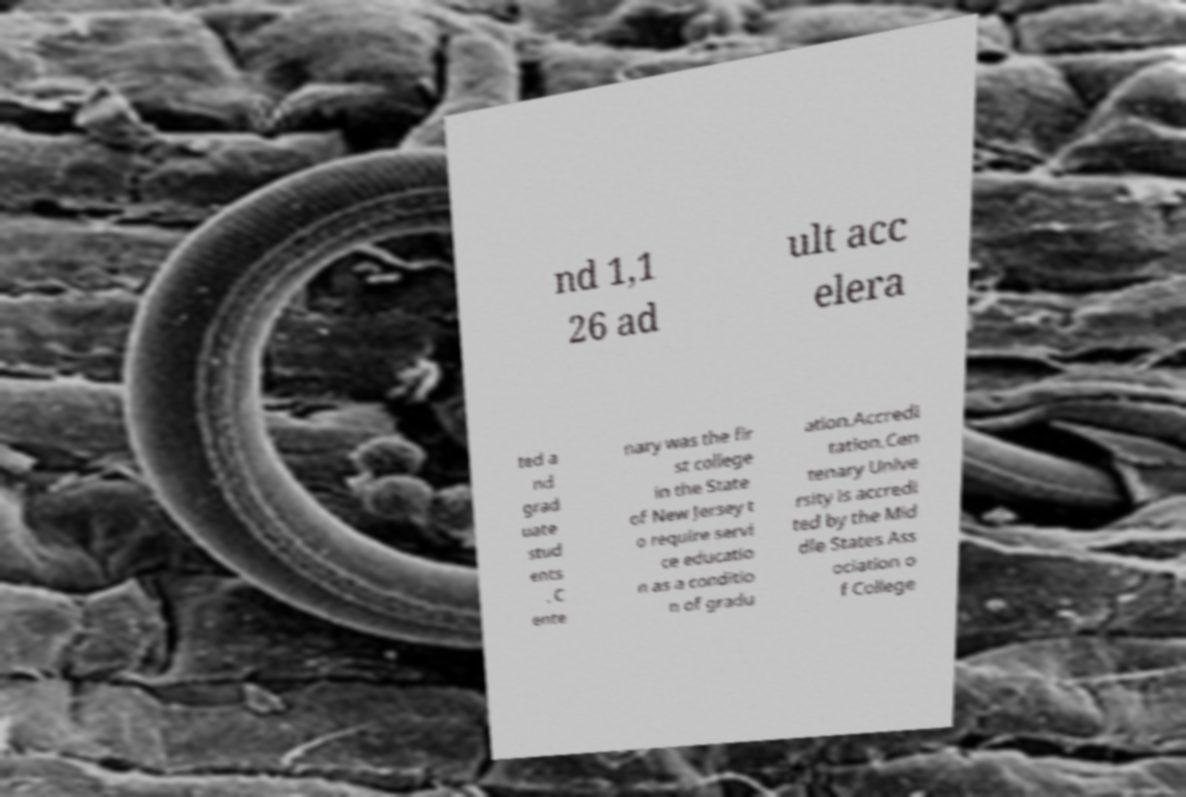Can you accurately transcribe the text from the provided image for me? nd 1,1 26 ad ult acc elera ted a nd grad uate stud ents . C ente nary was the fir st college in the State of New Jersey t o require servi ce educatio n as a conditio n of gradu ation.Accredi tation.Cen tenary Unive rsity is accredi ted by the Mid dle States Ass ociation o f College 